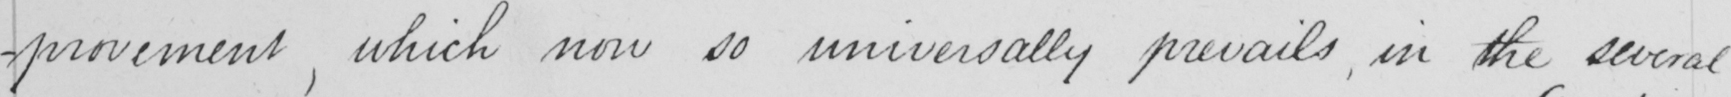Transcribe the text shown in this historical manuscript line. -provement , which now so universally prevails , in the several 